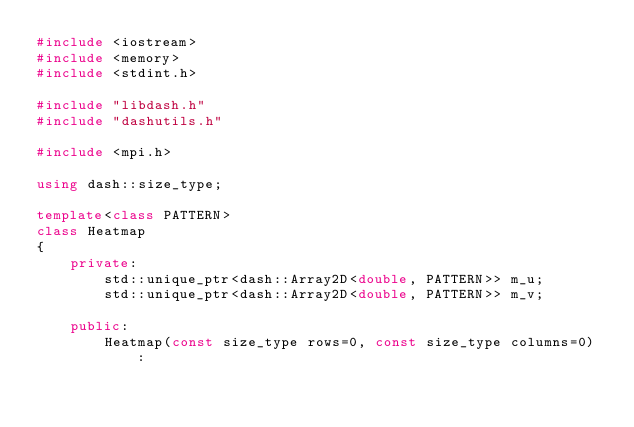Convert code to text. <code><loc_0><loc_0><loc_500><loc_500><_C++_>#include <iostream>
#include <memory>
#include <stdint.h>

#include "libdash.h"
#include "dashutils.h"

#include <mpi.h>

using dash::size_type;

template<class PATTERN>
class Heatmap
{
    private:
        std::unique_ptr<dash::Array2D<double, PATTERN>> m_u;
        std::unique_ptr<dash::Array2D<double, PATTERN>> m_v;

    public:
        Heatmap(const size_type rows=0, const size_type columns=0) :</code> 